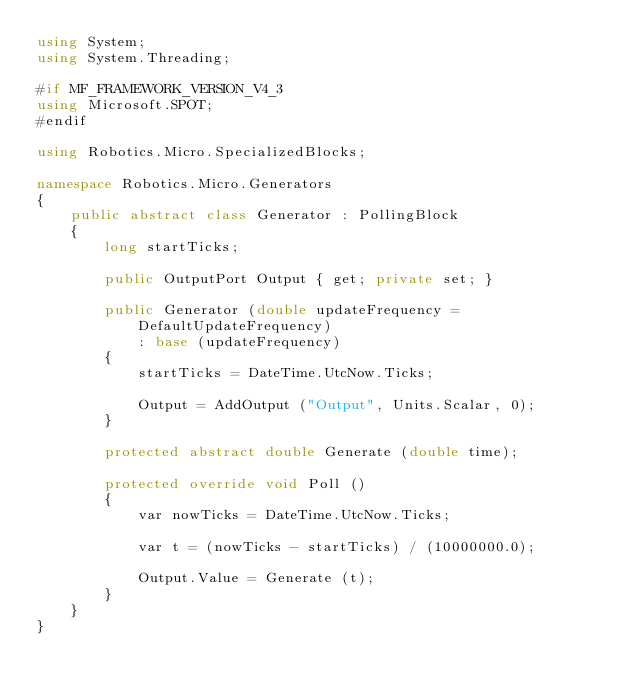Convert code to text. <code><loc_0><loc_0><loc_500><loc_500><_C#_>using System;
using System.Threading;

#if MF_FRAMEWORK_VERSION_V4_3
using Microsoft.SPOT;
#endif

using Robotics.Micro.SpecializedBlocks;

namespace Robotics.Micro.Generators
{
    public abstract class Generator : PollingBlock
    {
        long startTicks;

        public OutputPort Output { get; private set; }

        public Generator (double updateFrequency = DefaultUpdateFrequency)
            : base (updateFrequency)
        {
            startTicks = DateTime.UtcNow.Ticks;

            Output = AddOutput ("Output", Units.Scalar, 0);
        }

        protected abstract double Generate (double time);

        protected override void Poll ()
        {
            var nowTicks = DateTime.UtcNow.Ticks;

            var t = (nowTicks - startTicks) / (10000000.0);

            Output.Value = Generate (t);
        }
    }
}
</code> 